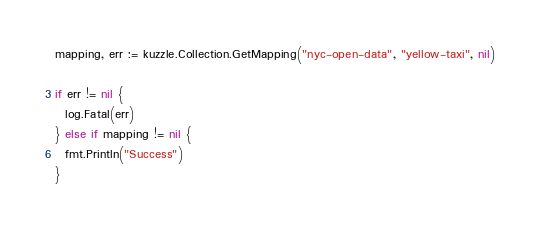<code> <loc_0><loc_0><loc_500><loc_500><_Go_>mapping, err := kuzzle.Collection.GetMapping("nyc-open-data", "yellow-taxi", nil)

if err != nil {
  log.Fatal(err)
} else if mapping != nil {
  fmt.Println("Success")
}
</code> 